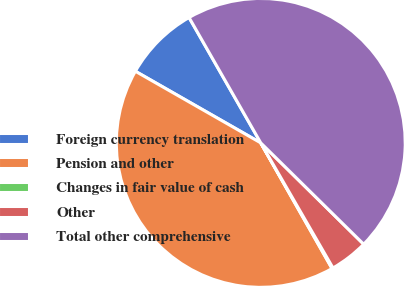<chart> <loc_0><loc_0><loc_500><loc_500><pie_chart><fcel>Foreign currency translation<fcel>Pension and other<fcel>Changes in fair value of cash<fcel>Other<fcel>Total other comprehensive<nl><fcel>8.47%<fcel>41.47%<fcel>0.12%<fcel>4.29%<fcel>45.64%<nl></chart> 